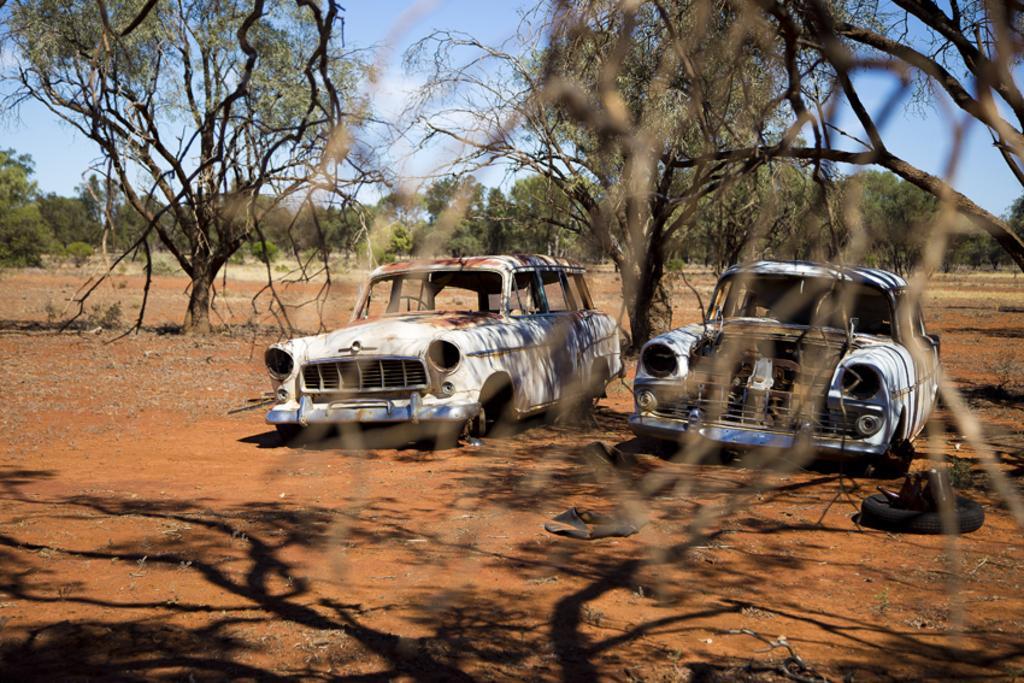Describe this image in one or two sentences. In the center of the image we can see two old dusty cars. In the background there are trees and sky. 